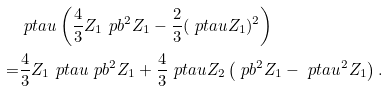<formula> <loc_0><loc_0><loc_500><loc_500>& \ p t a u \left ( \frac { 4 } { 3 } Z _ { 1 } \ p b ^ { 2 } Z _ { 1 } - \frac { 2 } { 3 } ( \ p t a u Z _ { 1 } ) ^ { 2 } \right ) \\ = & \frac { 4 } { 3 } Z _ { 1 } \ p t a u \ p b ^ { 2 } Z _ { 1 } + \frac { 4 } { 3 } \ p t a u Z _ { 2 } \left ( \ p b ^ { 2 } Z _ { 1 } - \ p t a u ^ { 2 } Z _ { 1 } \right ) .</formula> 